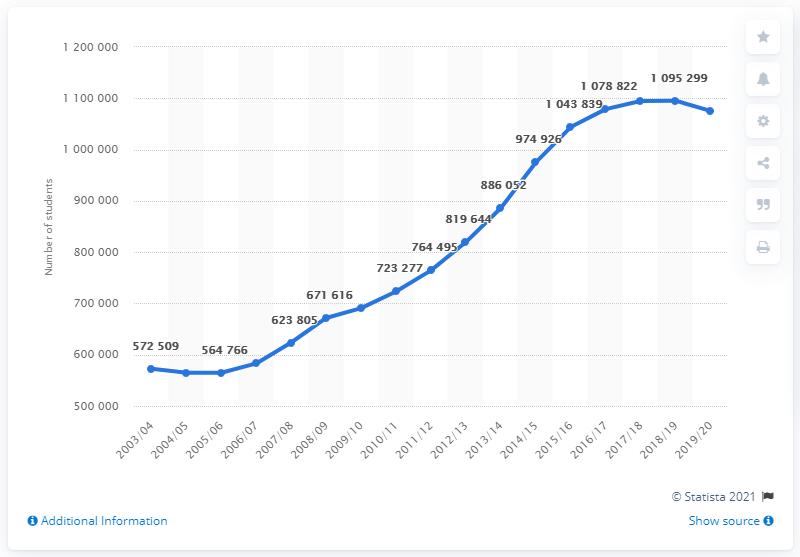Mention a couple of crucial points in this snapshot. In the 2019/2020 academic year, there were 1,075,496 international students studying in the United States. In 2019/2020, the number of international students in the United States began to increase, marking a turning point in the trend of declining international student enrollment. International students began attending universities in the United States during the academic year 2003/2004. 